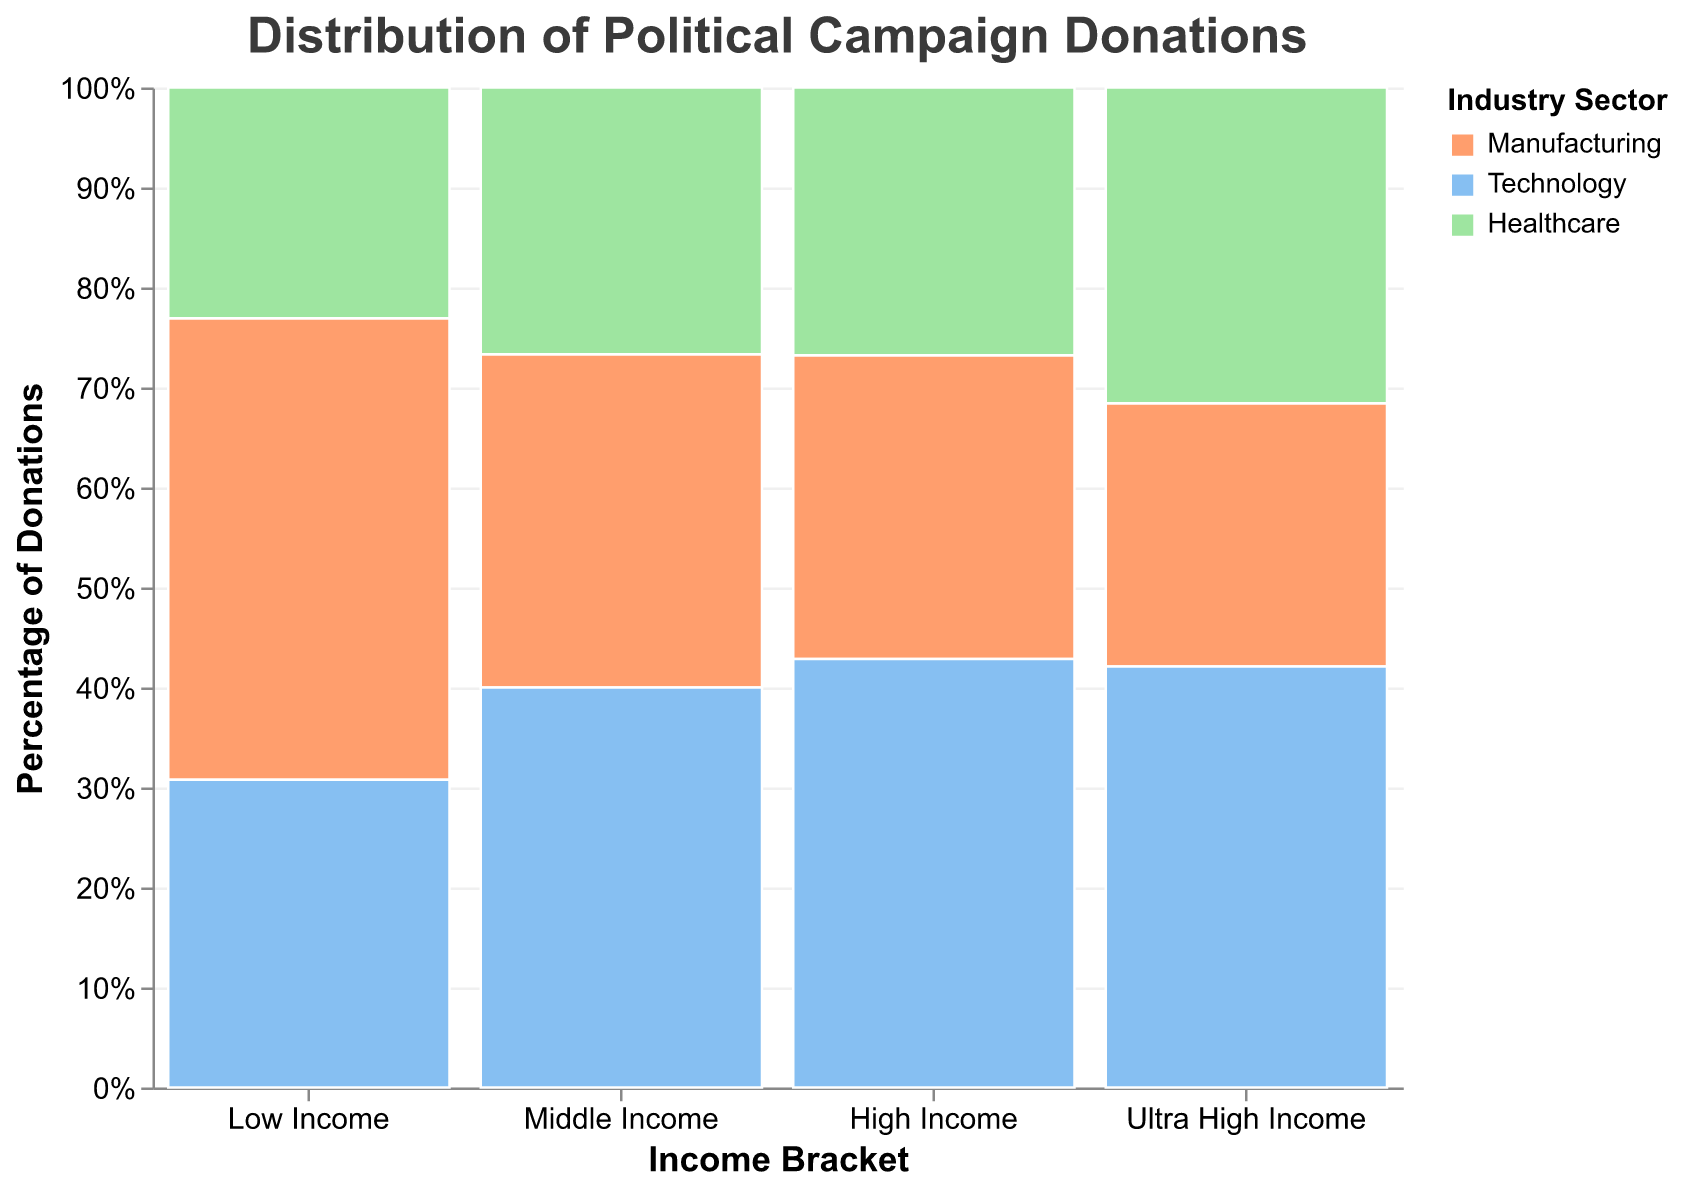What is the title of the plot? The title is placed at the top center of the plot and is formatted in bold with a size large enough to be easily read. It reads "Distribution of Political Campaign Donations".
Answer: Distribution of Political Campaign Donations Which income bracket has the highest total donation amount? The bracket with the largest area in the mosaic plot represents the highest total donation amount. The "Ultra High Income" bracket occupies the most space.
Answer: Ultra High Income Between the Low Income and Middle Income brackets, which industry sector contributes the least donations in the Middle Income bracket? Comparing the segments within the Middle Income bracket, the "Healthcare" sector appears smaller compared to the other sectors within this bracket.
Answer: Healthcare What percentage of donations in the Low Income bracket are from the Technology sector? Identify the segment for the Technology sector within the Low Income bracket and check the y-axis percentage scale to estimate the proportion.
Answer: 40% How do the donations from the Healthcare sector compare between the High Income and Ultra High Income brackets? Compare the relative sizes of the segments for the Healthcare sector in both the High Income and Ultra High Income brackets. The Healthcare sector in the Ultra High Income bracket is significantly larger than in the High Income bracket.
Answer: Ultra High Income contributes more What is the donation distribution for the Technology sector across different income brackets? Look at the relative sizes of the Technology sector segments across all income brackets: Low Income, Middle Income, High Income, and Ultra High Income. Notice that the segment size increases with income brackets.
Answer: Increasing from Low to Ultra High Income How much more does the Manufacturing sector in Ultra High Income donate compared to Middle Income? Calculate the difference between the donation amounts for the Manufacturing sector in Ultra High Income ($25,000,000) and Middle Income ($3,500,000).
Answer: $21,500,000 Which industry sector consistently contributes more in donations across all income brackets? Compare the segment sizes for each sector across all brackets. The Technology sector seems to consistently occupy larger portions in each bracket.
Answer: Technology Does the percentage of donations from the Healthcare sector increase or decrease as income brackets rise? Observe the percentage heights of the Healthcare sector across all income brackets. As we move from Low Income to Ultra High Income, the percentage generally increases.
Answer: Increase Which two industry sectors are closest in terms of donation percentage within the High Income bracket? Compare the heights of the segments in the High Income bracket for the three sectors. The Manufacturing and Healthcare sectors have closer sizes compared to the others.
Answer: Manufacturing and Healthcare 